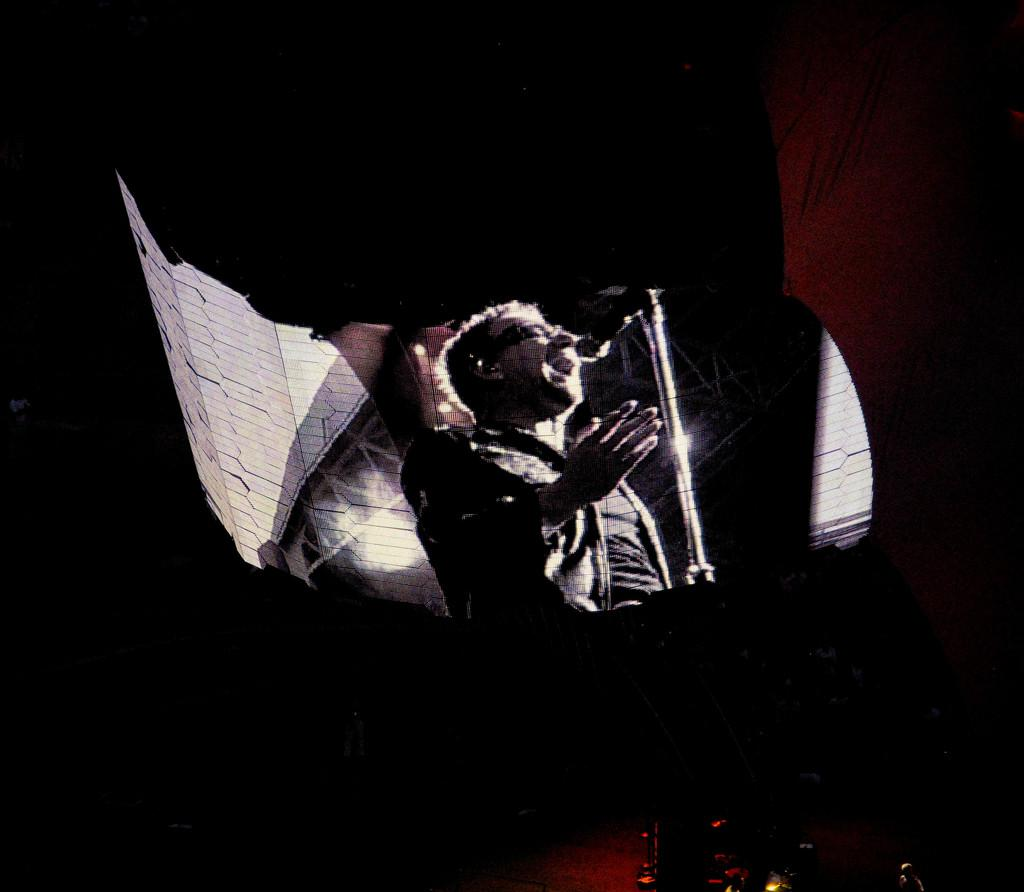What is the main object in the image? There is a screen in the image. What is happening on the screen? A person is singing on the screen. What is the person holding in front of them? There is a microphone in front of the person. What is the microphone attached to? The microphone is attached to a mic stand in front of the person. How is the background of the image depicted? The background of the image is blurred. How many verses are in the song being sung on the screen? There is no information about the song's lyrics or structure in the image, so it is impossible to determine the number of verses. 